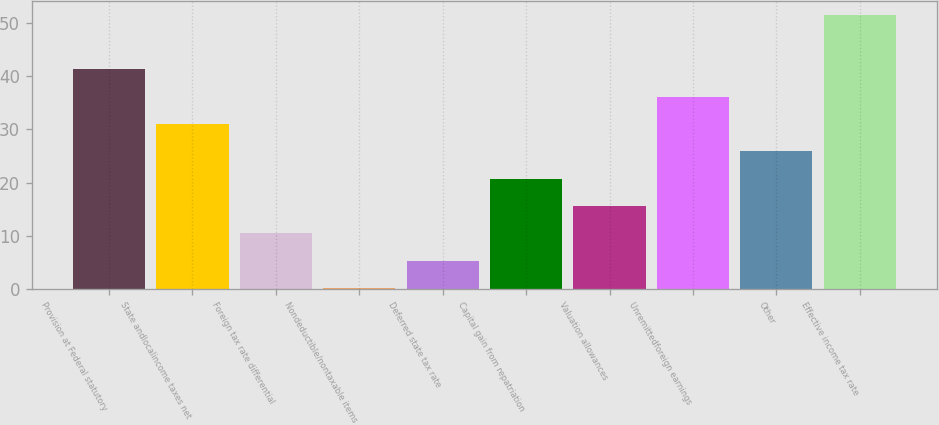Convert chart. <chart><loc_0><loc_0><loc_500><loc_500><bar_chart><fcel>Provision at Federal statutory<fcel>State andlocalincome taxes net<fcel>Foreign tax rate differential<fcel>Nondeductible/nontaxable items<fcel>Deferred state tax rate<fcel>Capital gain from repatriation<fcel>Valuation allowances<fcel>Unremittedforeign earnings<fcel>Other<fcel>Effective income tax rate<nl><fcel>41.32<fcel>31.04<fcel>10.48<fcel>0.2<fcel>5.34<fcel>20.76<fcel>15.62<fcel>36.18<fcel>25.9<fcel>51.6<nl></chart> 